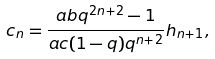Convert formula to latex. <formula><loc_0><loc_0><loc_500><loc_500>c _ { n } = \frac { a b q ^ { 2 n + 2 } - 1 } { a c ( 1 - q ) q ^ { n + 2 } } h _ { n + 1 } ,</formula> 